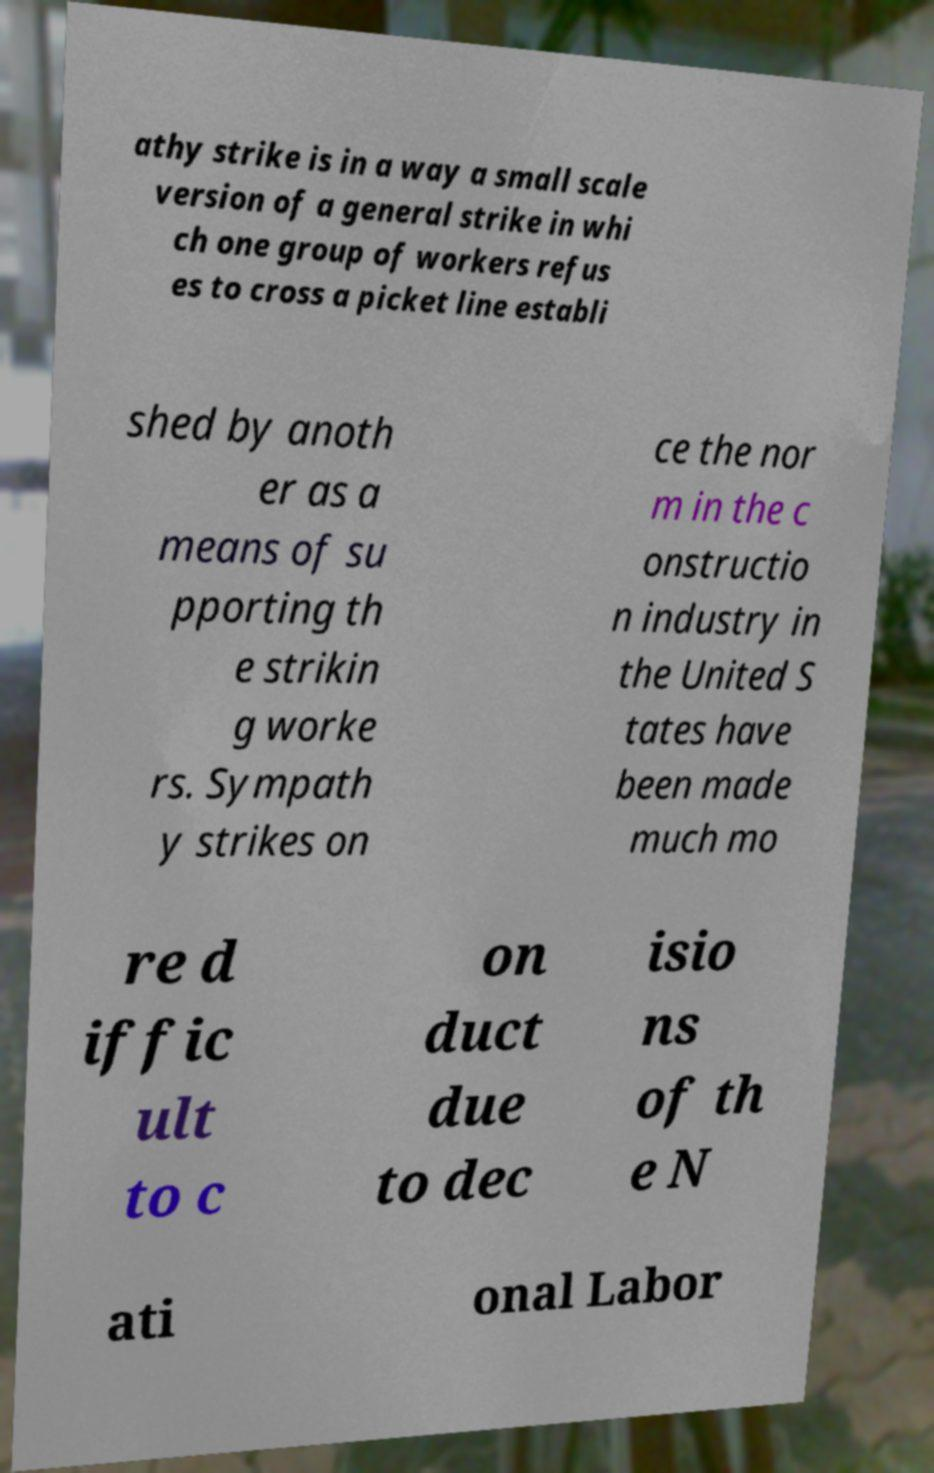There's text embedded in this image that I need extracted. Can you transcribe it verbatim? athy strike is in a way a small scale version of a general strike in whi ch one group of workers refus es to cross a picket line establi shed by anoth er as a means of su pporting th e strikin g worke rs. Sympath y strikes on ce the nor m in the c onstructio n industry in the United S tates have been made much mo re d iffic ult to c on duct due to dec isio ns of th e N ati onal Labor 